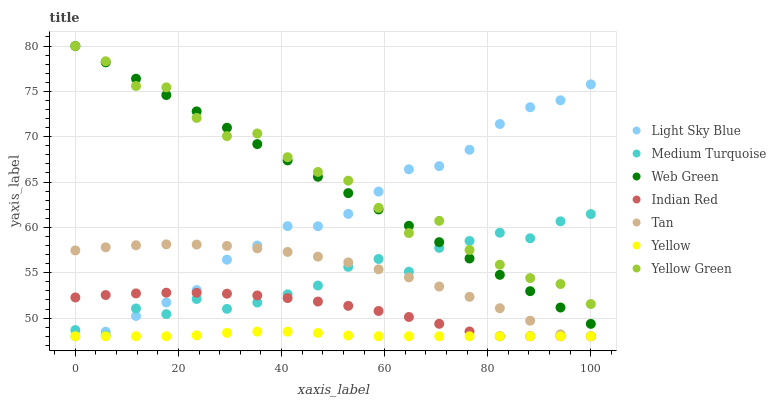Does Yellow have the minimum area under the curve?
Answer yes or no. Yes. Does Yellow Green have the maximum area under the curve?
Answer yes or no. Yes. Does Light Sky Blue have the minimum area under the curve?
Answer yes or no. No. Does Light Sky Blue have the maximum area under the curve?
Answer yes or no. No. Is Web Green the smoothest?
Answer yes or no. Yes. Is Yellow Green the roughest?
Answer yes or no. Yes. Is Yellow the smoothest?
Answer yes or no. No. Is Yellow the roughest?
Answer yes or no. No. Does Yellow have the lowest value?
Answer yes or no. Yes. Does Web Green have the lowest value?
Answer yes or no. No. Does Yellow Green have the highest value?
Answer yes or no. Yes. Does Light Sky Blue have the highest value?
Answer yes or no. No. Is Yellow less than Web Green?
Answer yes or no. Yes. Is Yellow Green greater than Tan?
Answer yes or no. Yes. Does Medium Turquoise intersect Indian Red?
Answer yes or no. Yes. Is Medium Turquoise less than Indian Red?
Answer yes or no. No. Is Medium Turquoise greater than Indian Red?
Answer yes or no. No. Does Yellow intersect Web Green?
Answer yes or no. No. 